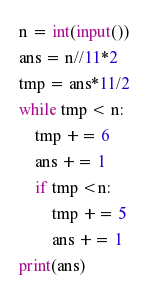<code> <loc_0><loc_0><loc_500><loc_500><_Python_>n = int(input())
ans = n//11*2
tmp = ans*11/2
while tmp < n:
    tmp += 6
    ans += 1
    if tmp <n:
        tmp += 5
        ans += 1
print(ans)</code> 